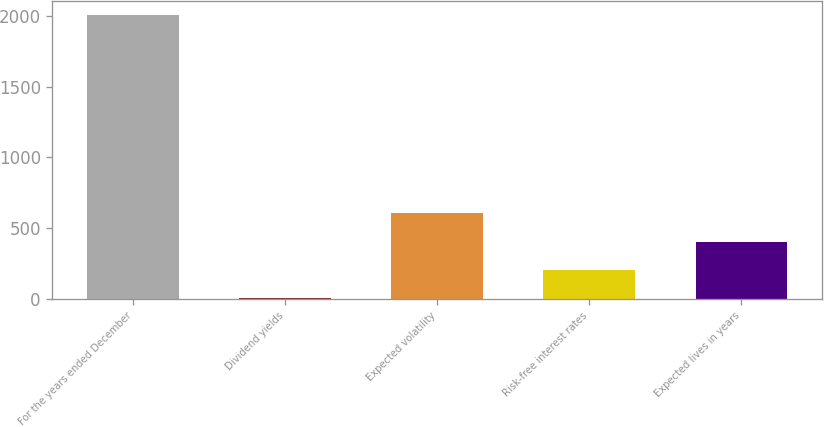<chart> <loc_0><loc_0><loc_500><loc_500><bar_chart><fcel>For the years ended December<fcel>Dividend yields<fcel>Expected volatility<fcel>Risk-free interest rates<fcel>Expected lives in years<nl><fcel>2008<fcel>2.4<fcel>604.08<fcel>202.96<fcel>403.52<nl></chart> 